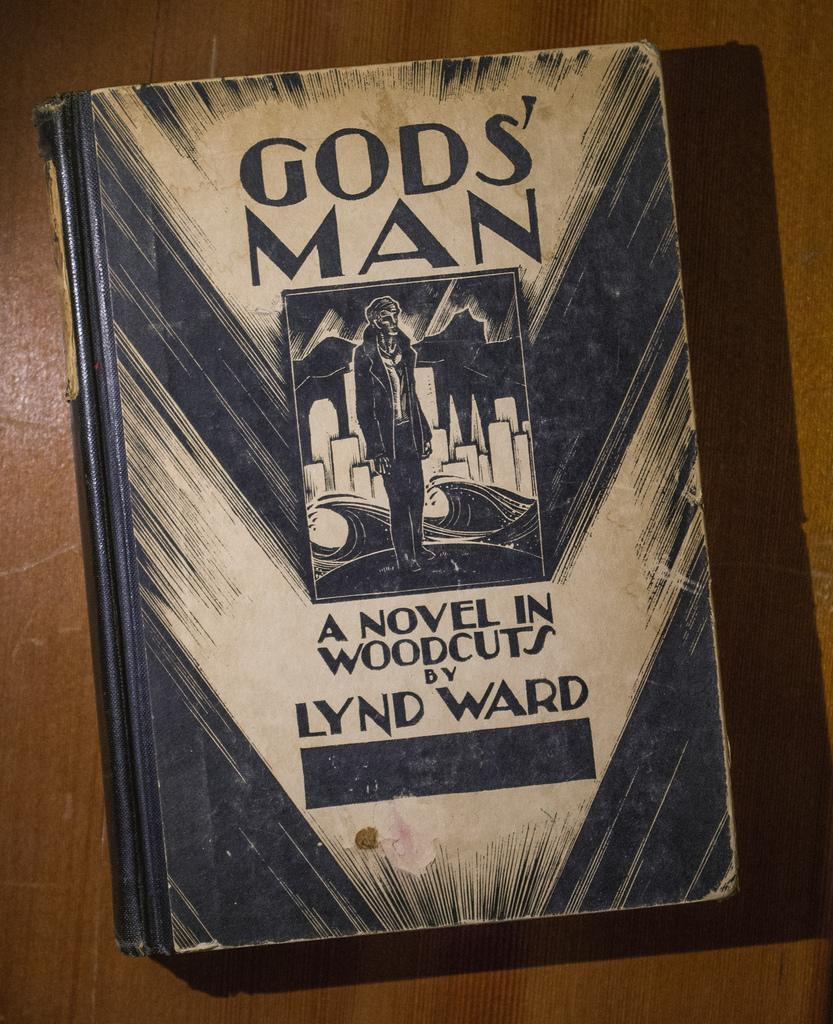<image>
Relay a brief, clear account of the picture shown. A novel titled "Gods Man" a novel in woodcuts by Lynd Ward. 